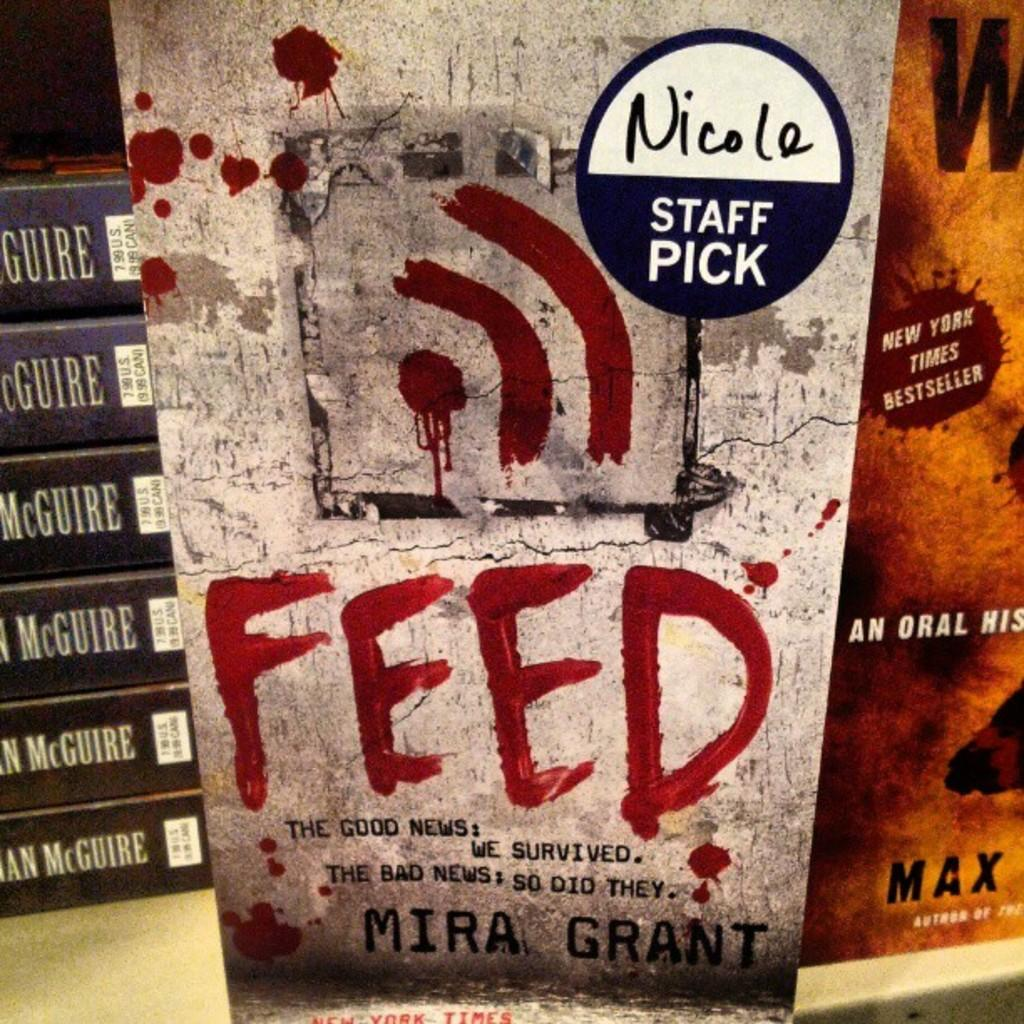<image>
Provide a brief description of the given image. A staff pick sticker on the cover of the book FEED arranged on a table with other books. 